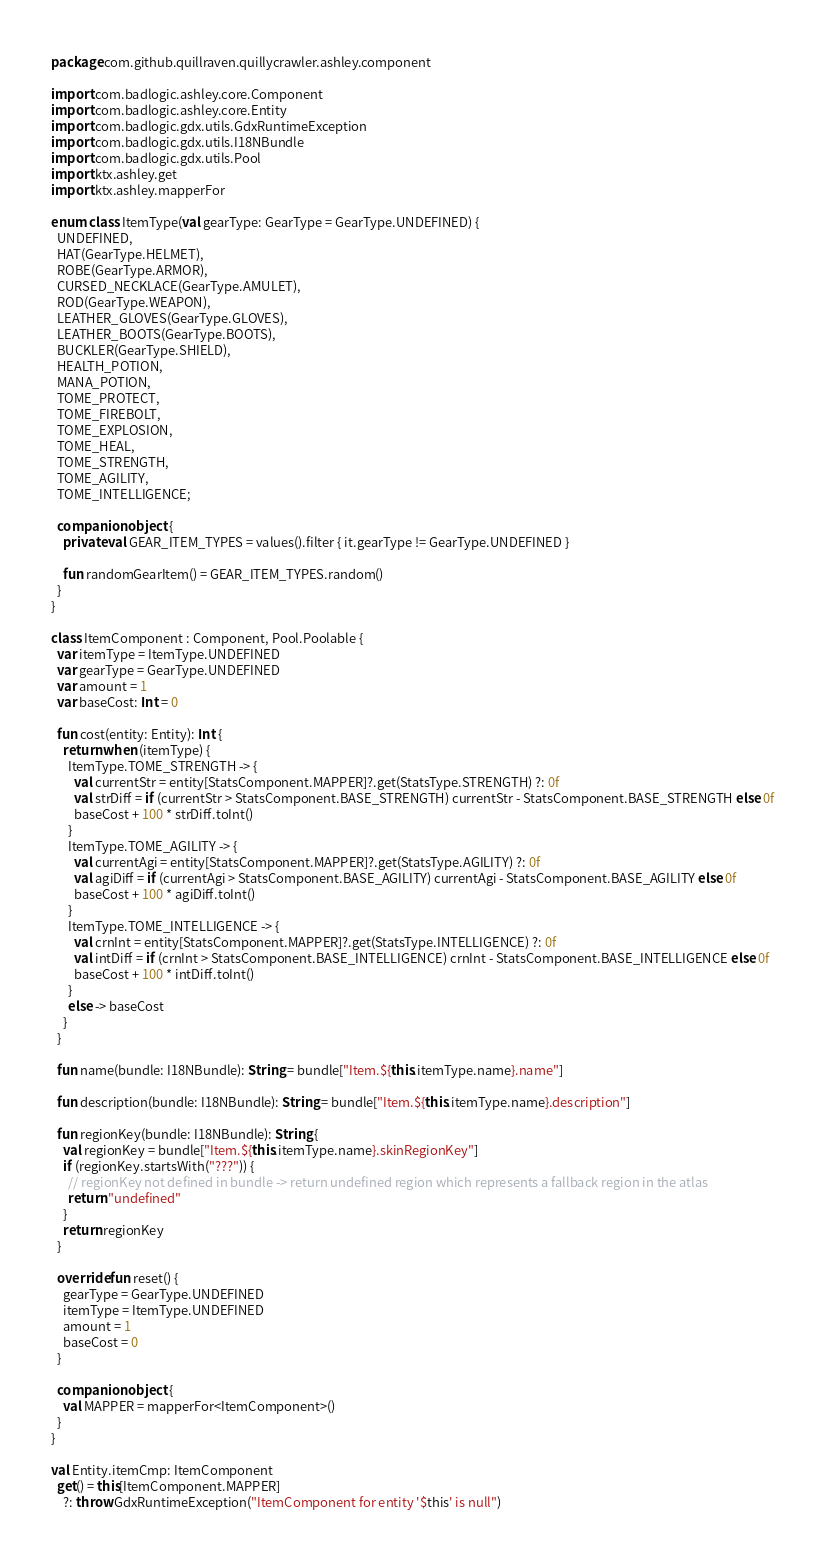Convert code to text. <code><loc_0><loc_0><loc_500><loc_500><_Kotlin_>package com.github.quillraven.quillycrawler.ashley.component

import com.badlogic.ashley.core.Component
import com.badlogic.ashley.core.Entity
import com.badlogic.gdx.utils.GdxRuntimeException
import com.badlogic.gdx.utils.I18NBundle
import com.badlogic.gdx.utils.Pool
import ktx.ashley.get
import ktx.ashley.mapperFor

enum class ItemType(val gearType: GearType = GearType.UNDEFINED) {
  UNDEFINED,
  HAT(GearType.HELMET),
  ROBE(GearType.ARMOR),
  CURSED_NECKLACE(GearType.AMULET),
  ROD(GearType.WEAPON),
  LEATHER_GLOVES(GearType.GLOVES),
  LEATHER_BOOTS(GearType.BOOTS),
  BUCKLER(GearType.SHIELD),
  HEALTH_POTION,
  MANA_POTION,
  TOME_PROTECT,
  TOME_FIREBOLT,
  TOME_EXPLOSION,
  TOME_HEAL,
  TOME_STRENGTH,
  TOME_AGILITY,
  TOME_INTELLIGENCE;

  companion object {
    private val GEAR_ITEM_TYPES = values().filter { it.gearType != GearType.UNDEFINED }

    fun randomGearItem() = GEAR_ITEM_TYPES.random()
  }
}

class ItemComponent : Component, Pool.Poolable {
  var itemType = ItemType.UNDEFINED
  var gearType = GearType.UNDEFINED
  var amount = 1
  var baseCost: Int = 0

  fun cost(entity: Entity): Int {
    return when (itemType) {
      ItemType.TOME_STRENGTH -> {
        val currentStr = entity[StatsComponent.MAPPER]?.get(StatsType.STRENGTH) ?: 0f
        val strDiff = if (currentStr > StatsComponent.BASE_STRENGTH) currentStr - StatsComponent.BASE_STRENGTH else 0f
        baseCost + 100 * strDiff.toInt()
      }
      ItemType.TOME_AGILITY -> {
        val currentAgi = entity[StatsComponent.MAPPER]?.get(StatsType.AGILITY) ?: 0f
        val agiDiff = if (currentAgi > StatsComponent.BASE_AGILITY) currentAgi - StatsComponent.BASE_AGILITY else 0f
        baseCost + 100 * agiDiff.toInt()
      }
      ItemType.TOME_INTELLIGENCE -> {
        val crnInt = entity[StatsComponent.MAPPER]?.get(StatsType.INTELLIGENCE) ?: 0f
        val intDiff = if (crnInt > StatsComponent.BASE_INTELLIGENCE) crnInt - StatsComponent.BASE_INTELLIGENCE else 0f
        baseCost + 100 * intDiff.toInt()
      }
      else -> baseCost
    }
  }

  fun name(bundle: I18NBundle): String = bundle["Item.${this.itemType.name}.name"]

  fun description(bundle: I18NBundle): String = bundle["Item.${this.itemType.name}.description"]

  fun regionKey(bundle: I18NBundle): String {
    val regionKey = bundle["Item.${this.itemType.name}.skinRegionKey"]
    if (regionKey.startsWith("???")) {
      // regionKey not defined in bundle -> return undefined region which represents a fallback region in the atlas
      return "undefined"
    }
    return regionKey
  }

  override fun reset() {
    gearType = GearType.UNDEFINED
    itemType = ItemType.UNDEFINED
    amount = 1
    baseCost = 0
  }

  companion object {
    val MAPPER = mapperFor<ItemComponent>()
  }
}

val Entity.itemCmp: ItemComponent
  get() = this[ItemComponent.MAPPER]
    ?: throw GdxRuntimeException("ItemComponent for entity '$this' is null")
</code> 